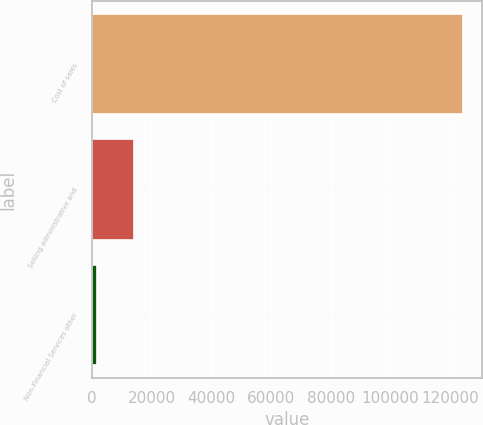<chart> <loc_0><loc_0><loc_500><loc_500><bar_chart><fcel>Cost of sales<fcel>Selling administrative and<fcel>Non-Financial Services other<nl><fcel>124446<fcel>14113.2<fcel>1854<nl></chart> 